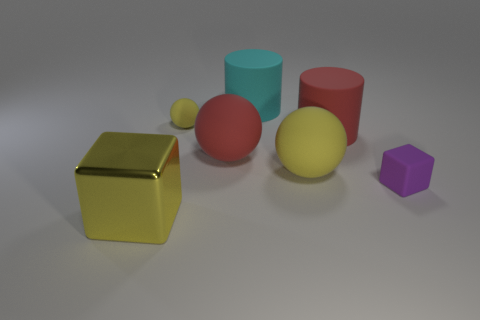Add 2 balls. How many objects exist? 9 Subtract all yellow spheres. How many spheres are left? 1 Subtract all red balls. How many balls are left? 2 Subtract 1 cylinders. How many cylinders are left? 1 Subtract all purple blocks. How many cyan balls are left? 0 Subtract all big matte things. Subtract all purple rubber objects. How many objects are left? 2 Add 4 big objects. How many big objects are left? 9 Add 2 large red rubber balls. How many large red rubber balls exist? 3 Subtract 0 gray balls. How many objects are left? 7 Subtract all cylinders. How many objects are left? 5 